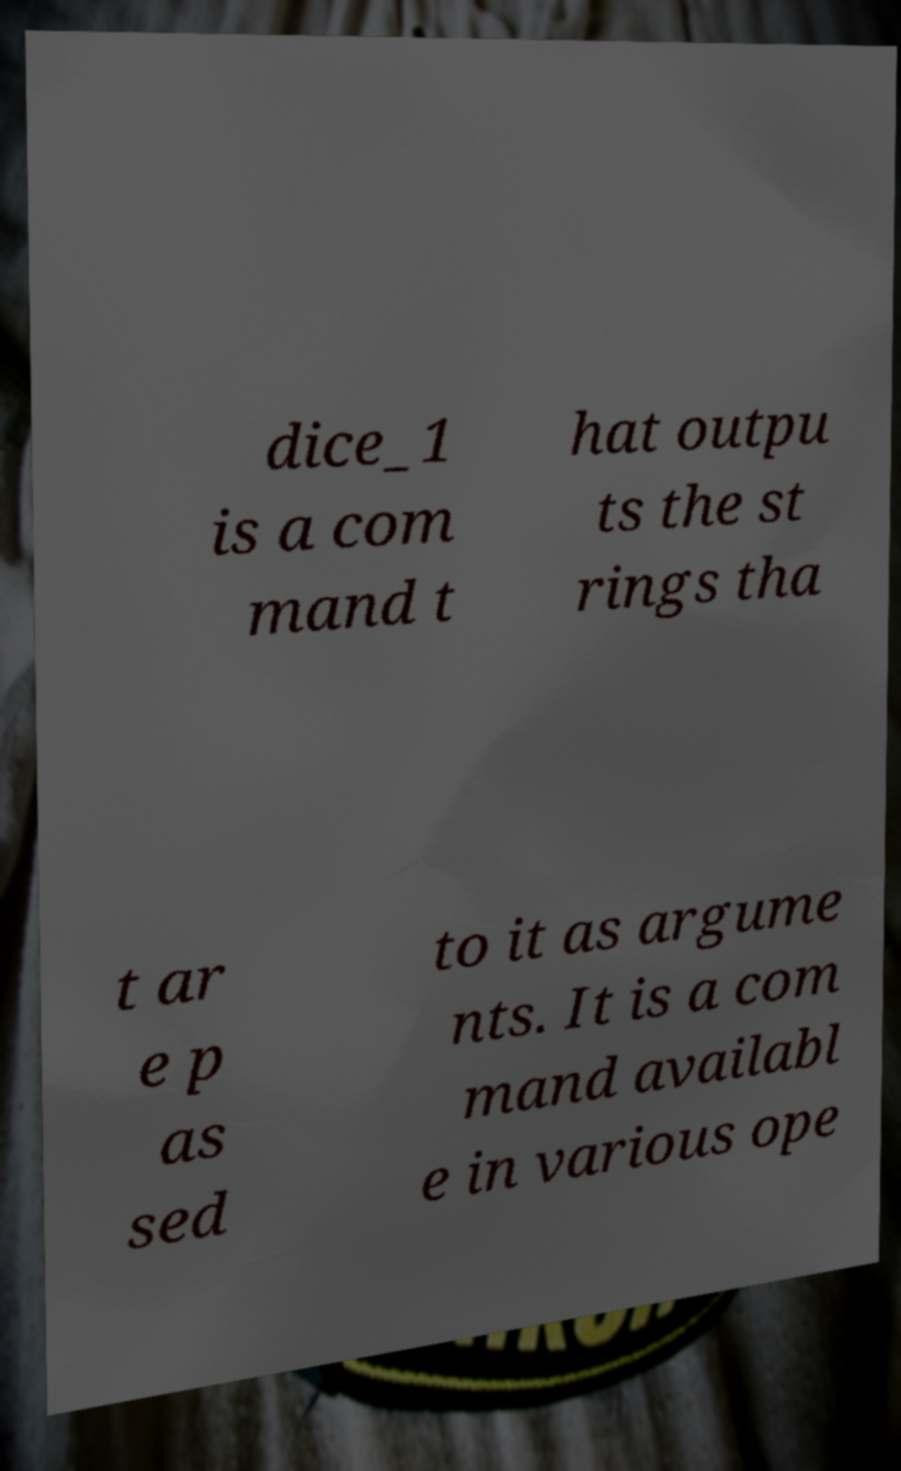Can you accurately transcribe the text from the provided image for me? dice_1 is a com mand t hat outpu ts the st rings tha t ar e p as sed to it as argume nts. It is a com mand availabl e in various ope 